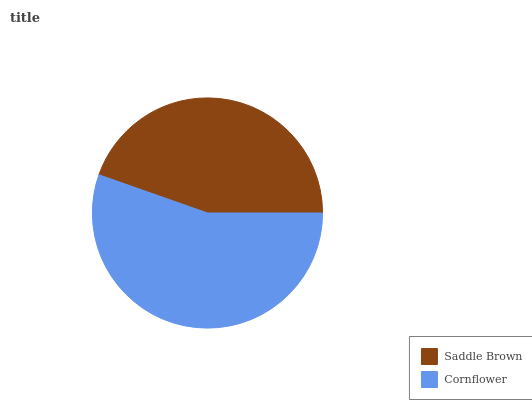Is Saddle Brown the minimum?
Answer yes or no. Yes. Is Cornflower the maximum?
Answer yes or no. Yes. Is Cornflower the minimum?
Answer yes or no. No. Is Cornflower greater than Saddle Brown?
Answer yes or no. Yes. Is Saddle Brown less than Cornflower?
Answer yes or no. Yes. Is Saddle Brown greater than Cornflower?
Answer yes or no. No. Is Cornflower less than Saddle Brown?
Answer yes or no. No. Is Cornflower the high median?
Answer yes or no. Yes. Is Saddle Brown the low median?
Answer yes or no. Yes. Is Saddle Brown the high median?
Answer yes or no. No. Is Cornflower the low median?
Answer yes or no. No. 